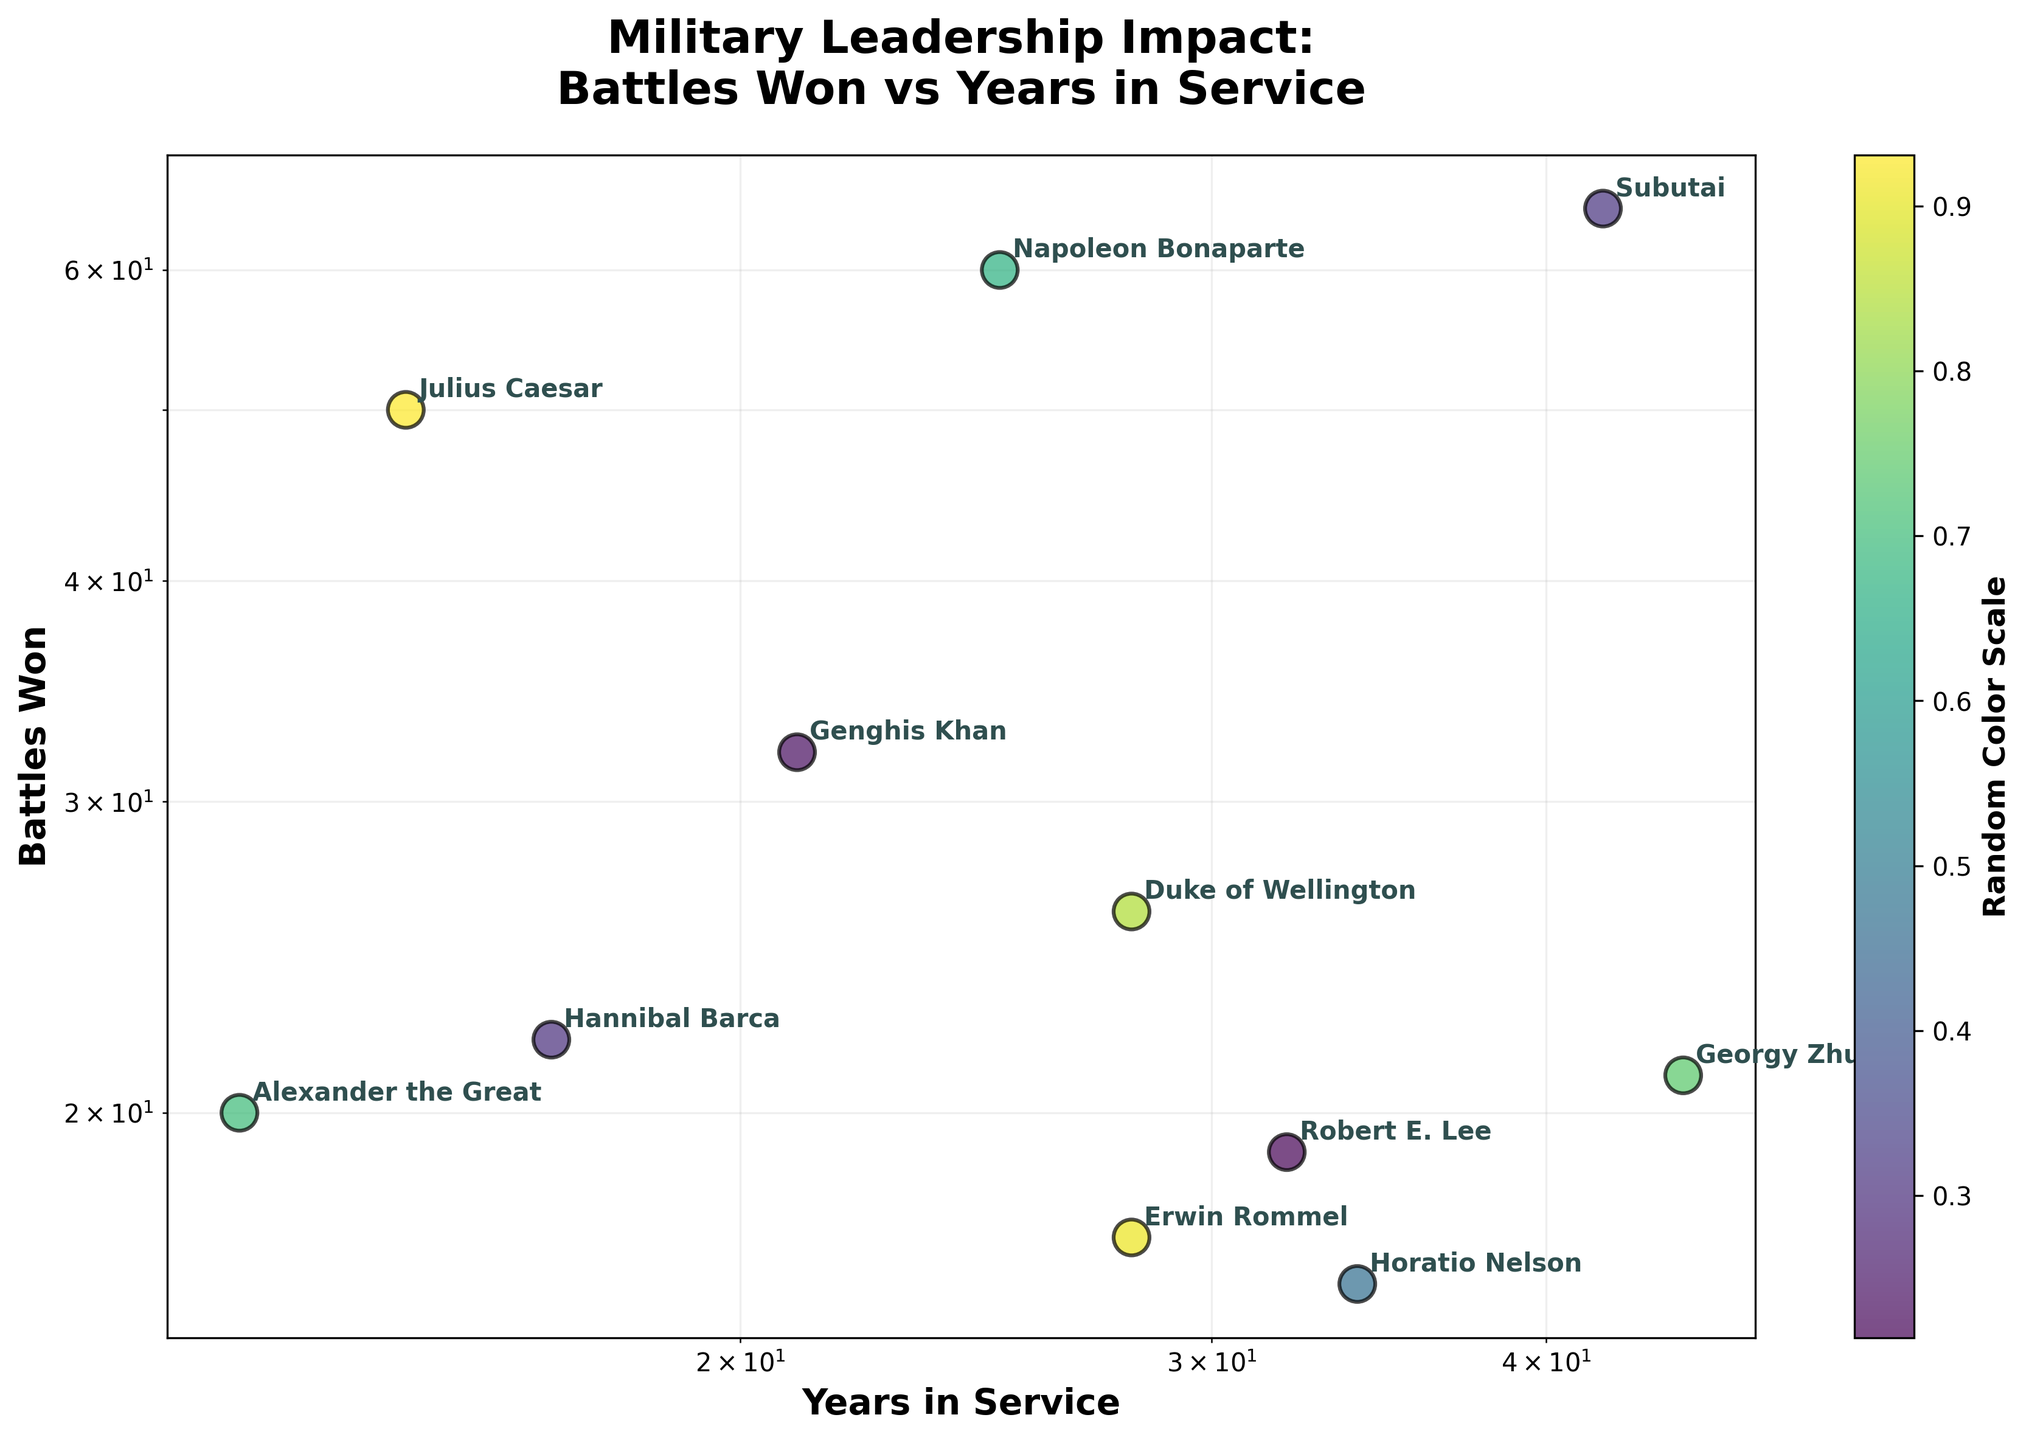What is the title of the figure? The title is displayed prominently at the top of the figure, usually in larger and bold text.
Answer: "Military Leadership Impact: Battles Won vs Years in Service" How many leaders are plotted on the scatter plot? By counting the unique names annotated next to the data points, the total number of leaders plotted can be determined.
Answer: 11 Which leader had the longest years in service? On the scatter plot, the x-axis represents the "Years in Service." The leader with the highest value on this axis is the one with the longest years in service.
Answer: Georgy Zhukov Which leader won the most battles? On the scatter plot, the y-axis represents the "Battles Won." The leader with the highest value on this axis is the one who won the most battles.
Answer: Subutai Who had more years in service, Genghis Khan or Napoleon Bonaparte? Compare the x-axis values for Genghis Khan and Napoleon Bonaparte. Genghis Khan served for 21 years, and Napoleon Bonaparte served for 25 years.
Answer: Napoleon Bonaparte What is the relationship between years in service and battles won? Observing the overall pattern of data points, we can identify whether there is a clear trend or correlation. In this case, the figure does not show a definitive correlation, indicating varied individual impacts.
Answer: Varied individual impacts; no clear correlation Who won more battles, Julius Caesar or Hannibal Barca? Compare the y-axis values for Julius Caesar and Hannibal Barca. Julius Caesar won 50 battles, while Hannibal Barca won 22 battles.
Answer: Julius Caesar Are there any leaders with more than 40 years of service? Check the x-axis to see if any data point corresponds to more than 40 years in service. Subutai and Georgy Zhukov have more than 40 years of service.
Answer: Yes, Subutai and Georgy Zhukov Is there any leader who won fewer than 20 battles? Examine the y-axis to find leaders whose values are below 20 on the logarithmic scale. Horatio Nelson and Robert E. Lee won fewer than 20 battles.
Answer: Yes, Horatio Nelson and Robert E. Lee What do the axes scales indicate about the distribution of data points? The use of logarithmic scales on both axes suggests that the data vary over several orders of magnitude, making it easier to visualize differences and patterns among several orders of magnitude.
Answer: Data vary significantly over multiple magnitudes 